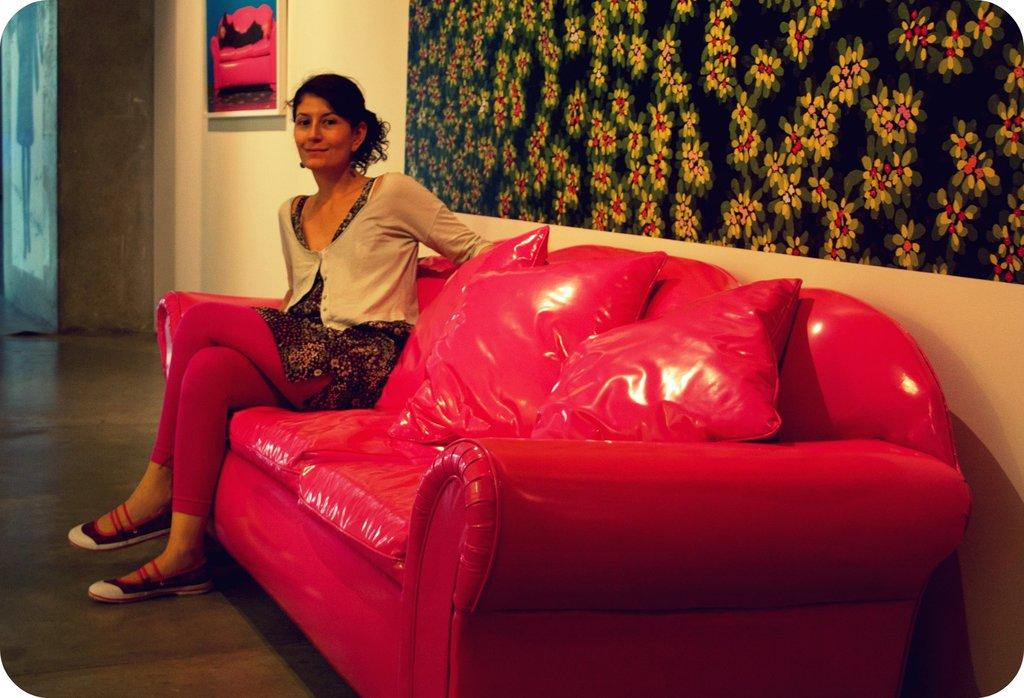What is the woman doing in the image? The woman is sitting on a couch. What can be seen on the couch besides the woman? There are cushions on the couch. What type of design is visible on the wall behind the woman? There is a floral design wall design behind the woman. How many mice are running on the woman's feet in the image? There are no mice present in the image, and the woman's feet are not visible. 